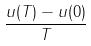Convert formula to latex. <formula><loc_0><loc_0><loc_500><loc_500>\frac { u ( T ) - u ( 0 ) } { T }</formula> 